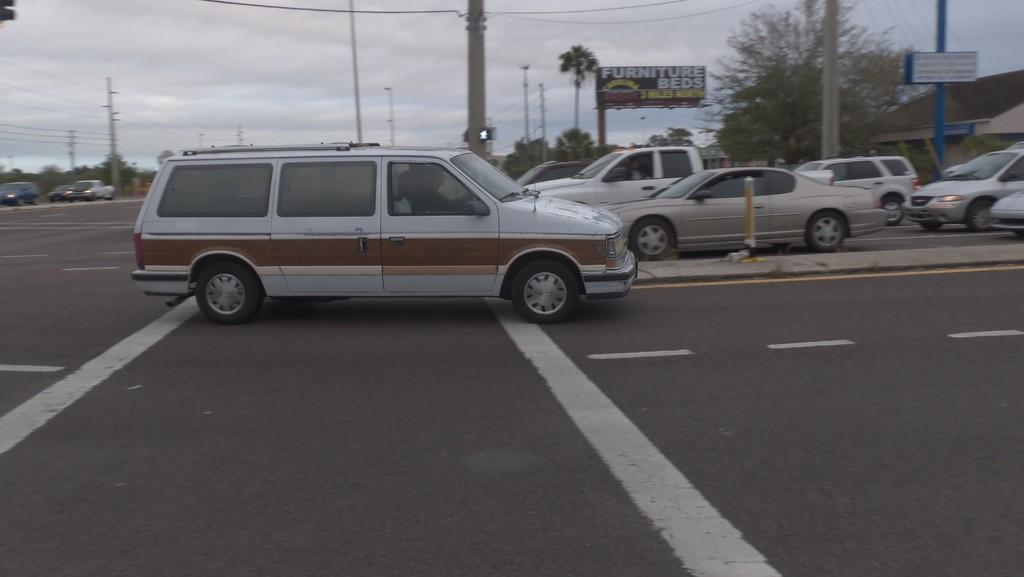What is happening on the road in the image? There are cars moving on the road in the image. What is located behind the car in the image? There is a banner behind the car. What structures can be seen in the image? There are poles present in the image. What type of vegetation is visible in the image? There are trees visible in the image. Can you tell me who is telling a joke in the image? There is no one telling a joke in the image; it features cars moving on the road, a banner, poles, and trees. 